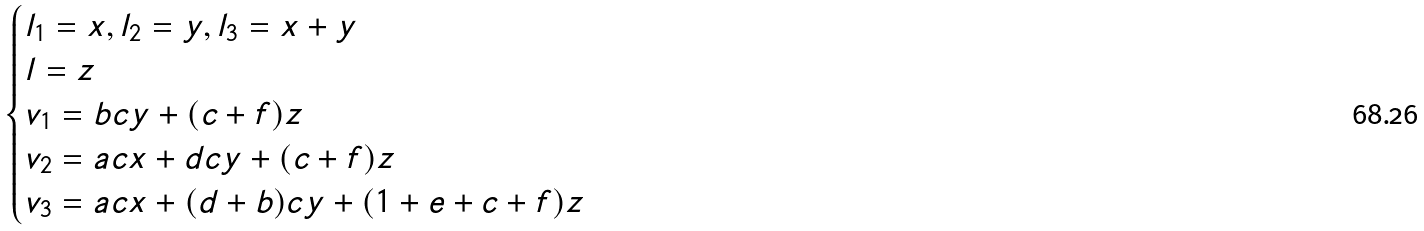<formula> <loc_0><loc_0><loc_500><loc_500>\begin{cases} l _ { 1 } = x , l _ { 2 } = y , l _ { 3 } = x + y \\ l = z \\ v _ { 1 } = b c y + ( c + f ) z \\ v _ { 2 } = a c x + d c y + ( c + f ) z \\ v _ { 3 } = a c x + ( d + b ) c y + ( 1 + e + c + f ) z \end{cases}</formula> 